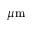Convert formula to latex. <formula><loc_0><loc_0><loc_500><loc_500>\mu m</formula> 